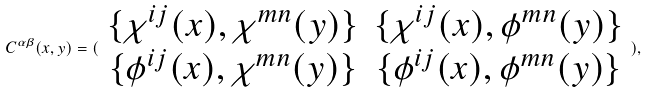Convert formula to latex. <formula><loc_0><loc_0><loc_500><loc_500>C ^ { \alpha \beta } ( x , y ) = ( \begin{array} { c c } \{ \chi ^ { i j } ( x ) , \chi ^ { m n } ( y ) \} & \{ \chi ^ { i j } ( x ) , \phi ^ { m n } ( y ) \} \\ \{ \phi ^ { i j } ( x ) , \chi ^ { m n } ( y ) \} & \{ \phi ^ { i j } ( x ) , \phi ^ { m n } ( y ) \} \end{array} ) ,</formula> 